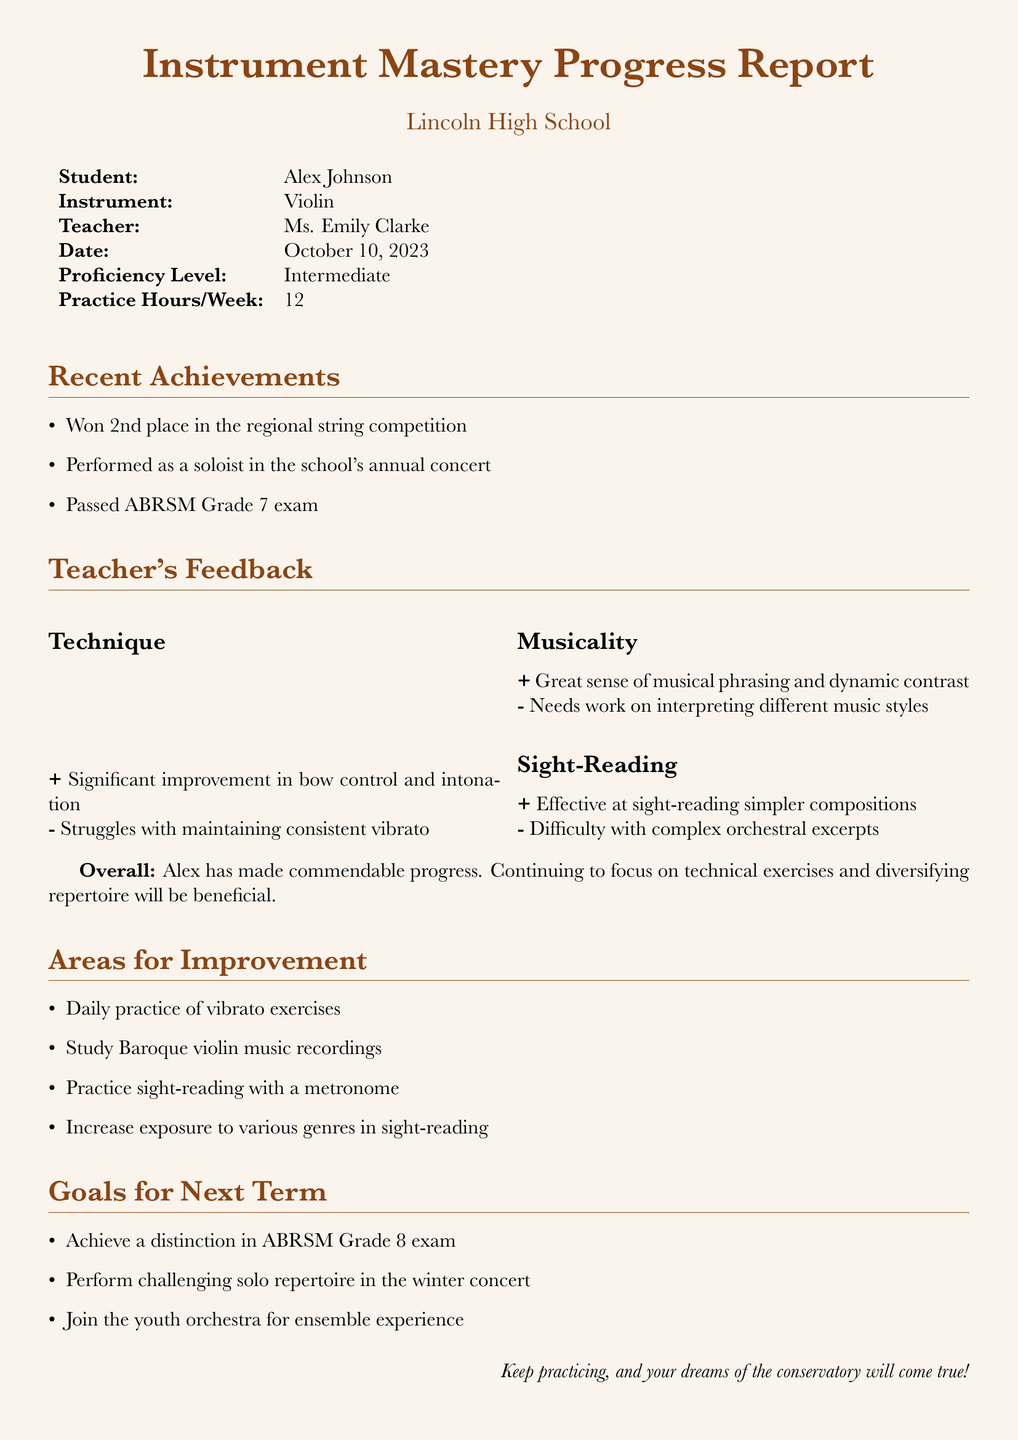What is the student's name? The student's name is listed at the top of the document.
Answer: Alex Johnson What instrument does the student play? The instrument played by the student is specified in the document.
Answer: Violin Who is the teacher? The teacher's name is provided in the report.
Answer: Ms. Emily Clarke What is the date of the report? The report includes a specific date at the top.
Answer: October 10, 2023 What is the proficiency level? The proficiency level is indicated in the document.
Answer: Intermediate What was one of the recent achievements? The report lists several achievements, including the student's performance.
Answer: Won 2nd place in the regional string competition What is one area for improvement? The document outlines specific areas where the student can improve.
Answer: Daily practice of vibrato exercises What is the goal for the next term? The document states specific goals for the upcoming term.
Answer: Achieve a distinction in ABRSM Grade 8 exam What positive feedback did the teacher provide about technique? The teacher's feedback section highlights positive aspects of the student's technique.
Answer: Significant improvement in bow control and intonation What does the overall summary note about the student's progress? The overall summary provides a general statement about the student's achievements.
Answer: Alex has made commendable progress 